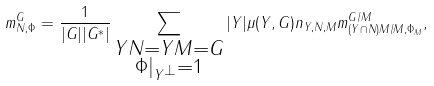Convert formula to latex. <formula><loc_0><loc_0><loc_500><loc_500>m ^ { G } _ { N , \Phi } = \frac { 1 } { | G | | G ^ { * } | } \sum _ { \substack { Y N = Y M = G \\ \Phi | _ { Y ^ { \bot } } = 1 } } | Y | \mu ( Y , G ) n _ { Y , N , M } m ^ { G / M } _ { ( Y \cap N ) M / M , \Phi _ { M } } ,</formula> 